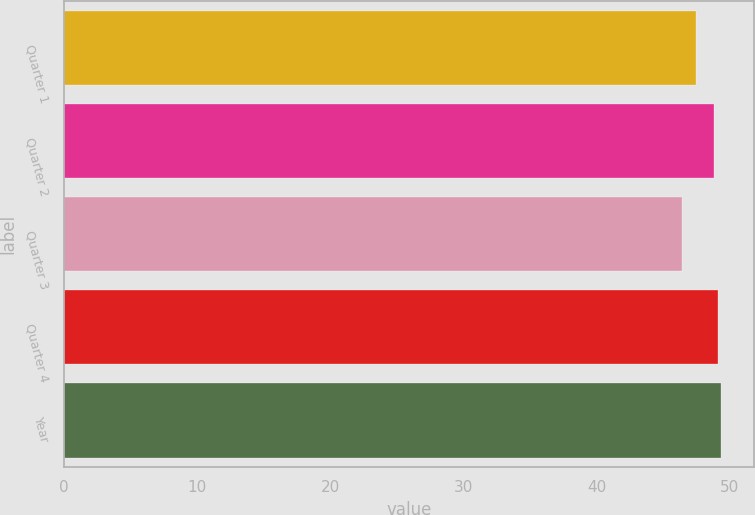Convert chart to OTSL. <chart><loc_0><loc_0><loc_500><loc_500><bar_chart><fcel>Quarter 1<fcel>Quarter 2<fcel>Quarter 3<fcel>Quarter 4<fcel>Year<nl><fcel>47.44<fcel>48.85<fcel>46.45<fcel>49.1<fcel>49.35<nl></chart> 